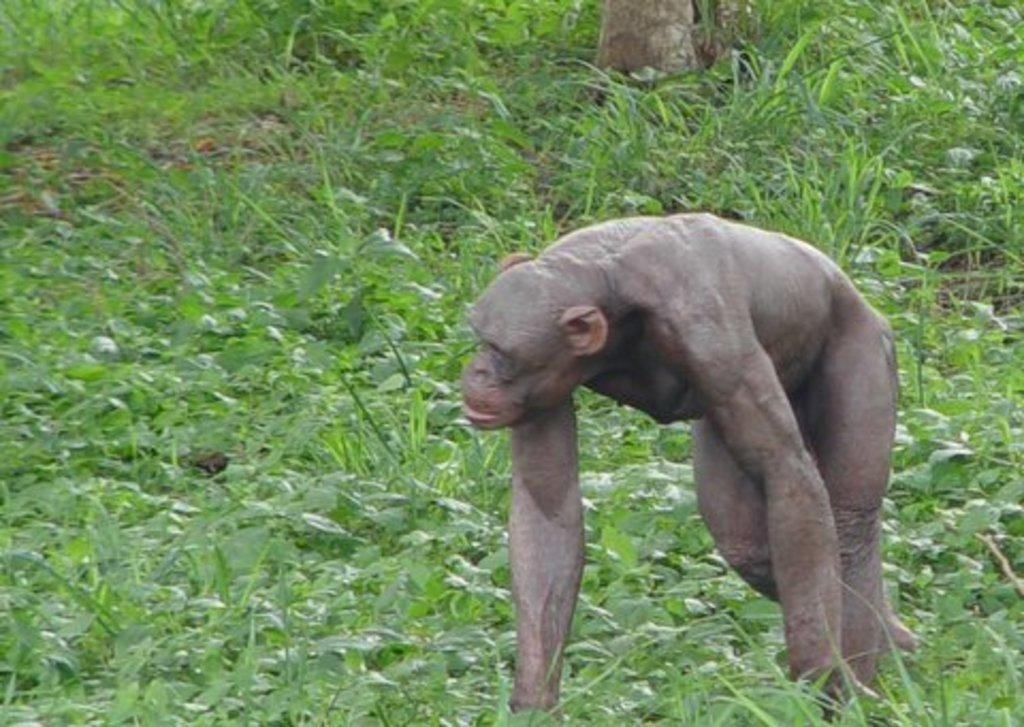What animal is present in the image? There is a monkey in the image. What is the monkey doing in the image? The monkey is walking. What type of surface is visible in the image? There is ground visible in the image. What is covering the ground in the image? The ground is covered with plants. How many combs are being used by the maid in the image? There is no maid or comb present in the image; it features a monkey walking on a ground covered with plants. 